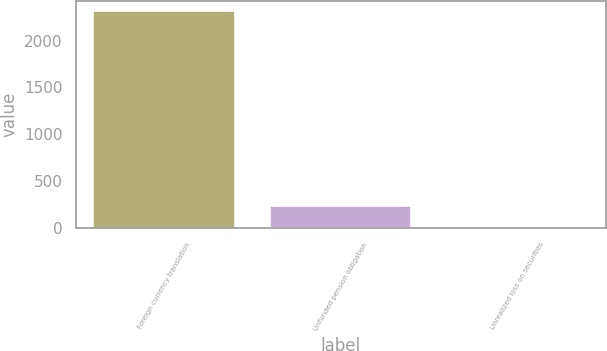Convert chart. <chart><loc_0><loc_0><loc_500><loc_500><bar_chart><fcel>Foreign currency translation<fcel>Unfunded pension obligation<fcel>Unrealized loss on securities<nl><fcel>2312<fcel>236.6<fcel>6<nl></chart> 